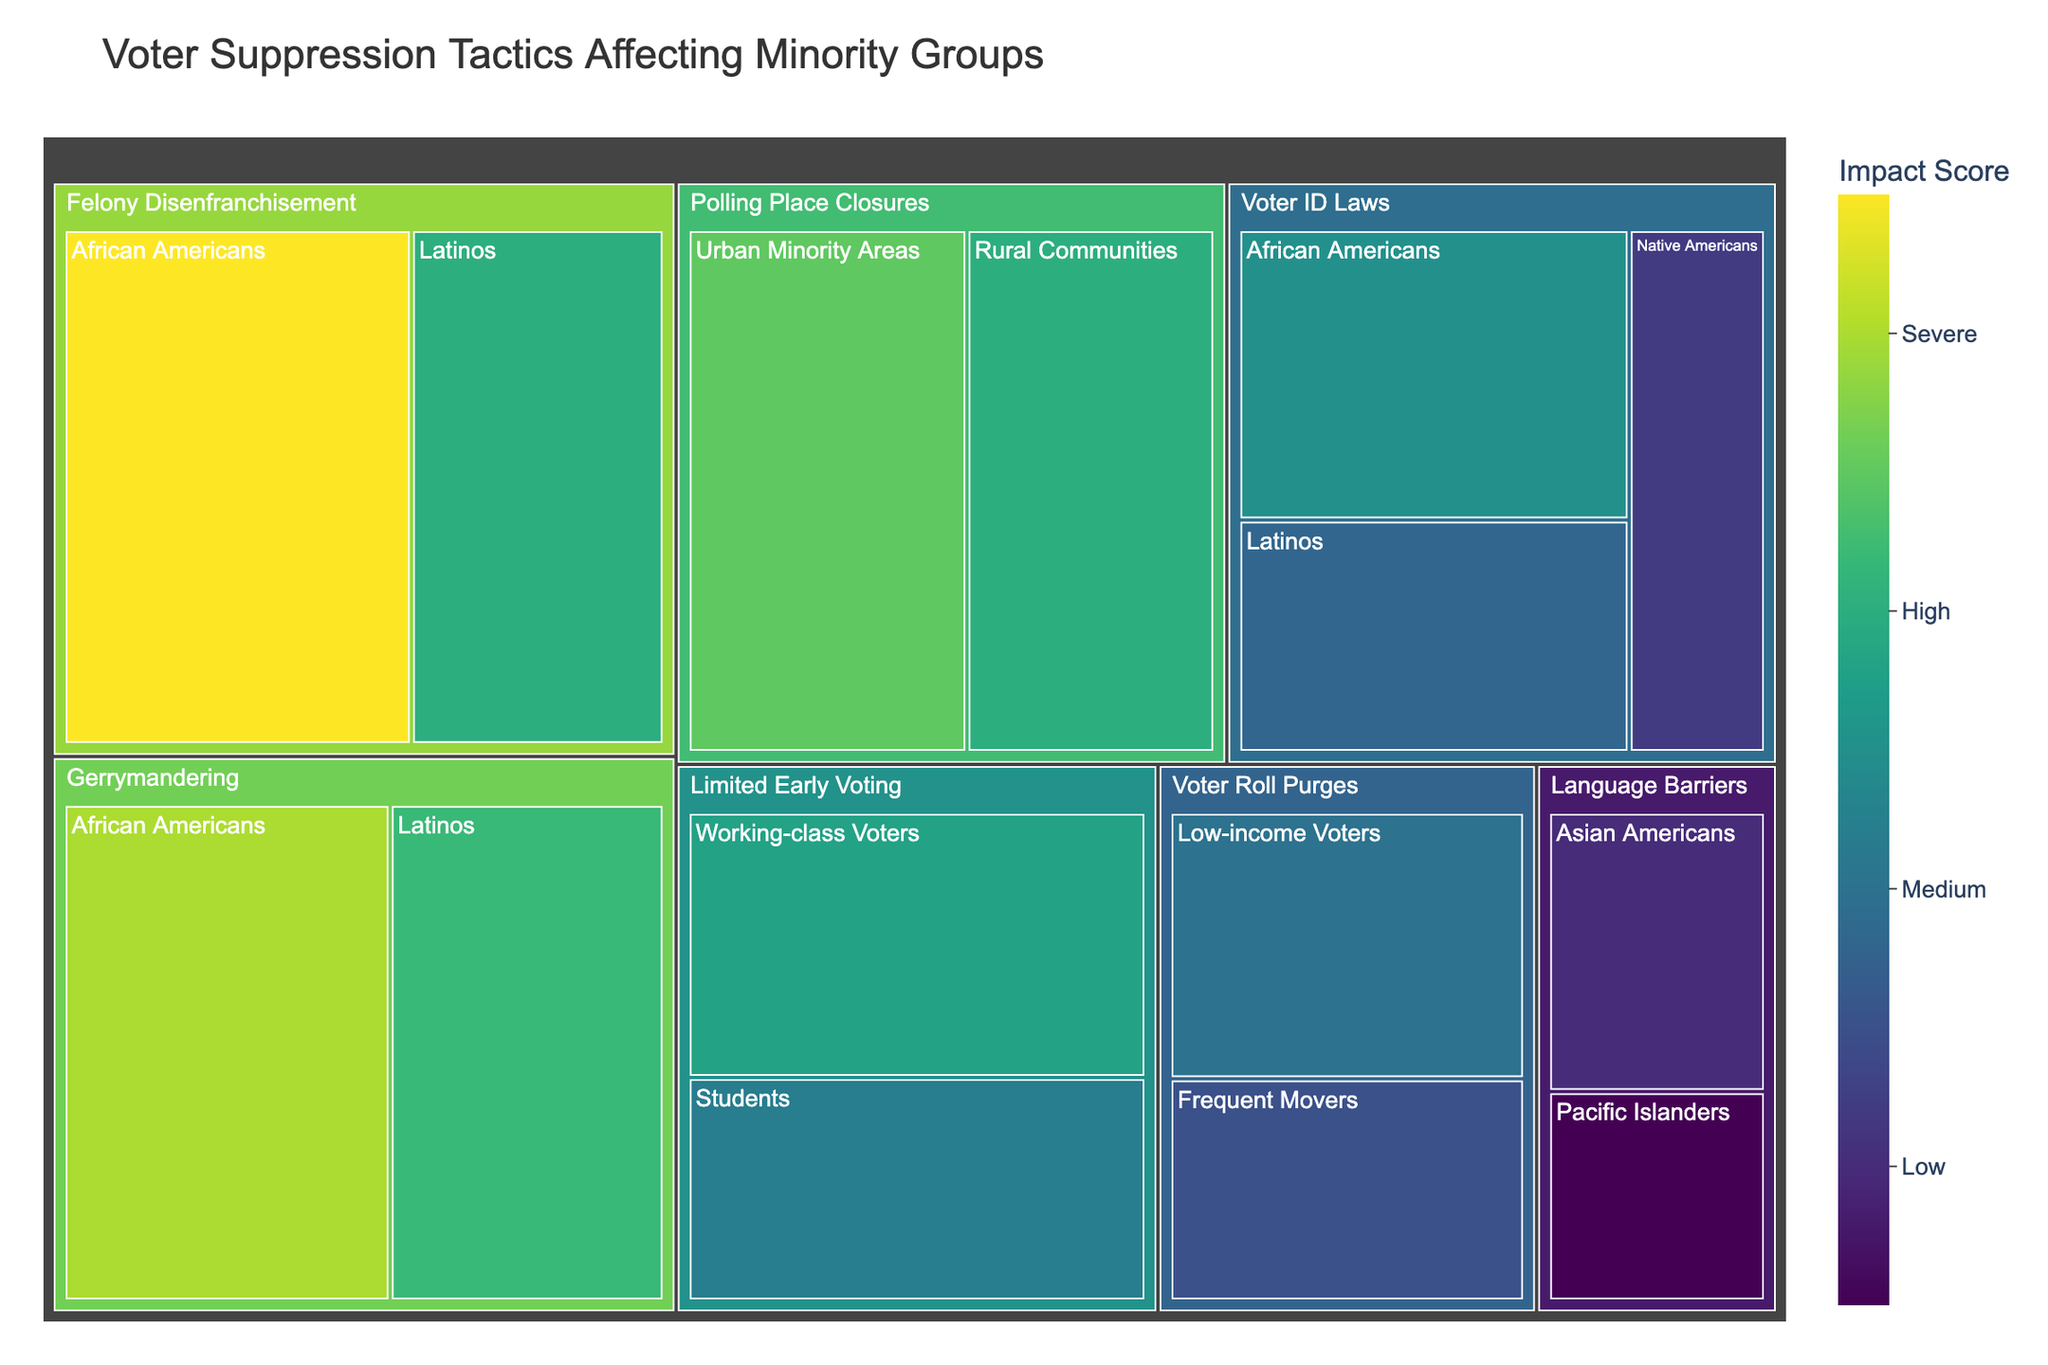What tactic has the highest impact on a particular minority group? Look for the subcategory with the largest value under each category; for example, "Felony Disenfranchisement" affects African Americans the most with a value of 55.
Answer: Felony Disenfranchisement on African Americans Which minority group is most affected by Voter ID laws? Under the "Voter ID Laws" category, compare the values: African Americans (35), Latinos (28), Native Americans (22); African Americans have the highest value.
Answer: African Americans What is the total impact score of Polling Place Closures on all affected communities? Sum the values under "Polling Place Closures": Rural Communities (40) + Urban Minority Areas (45) = 85.
Answer: 85 How does the impact of Limited Early Voting on Working-class Voters compare to that on Students? Compare the values under "Limited Early Voting": Working-class Voters (38) vs. Students (32).
Answer: Working-class Voters have a higher impact of 38 compared to Students with 32 What is the combined impact score of all Gerrymandering tactics? Sum the values under "Gerrymandering": African Americans (50) + Latinos (42) = 92.
Answer: 92 Which category has the most subcategories and what are they? Count the subcategories under each main category; the category with the highest count has 2 subcategories. For example, "Voter ID Laws" has three subcategories: African Americans, Latinos, and Native Americans.
Answer: Voter ID Laws with three subcategories What color represents the highest impact score on the treemap? Based on the color scale (Viridis), the highest impact score color represents values closer to the max, which are dark green.
Answer: Dark green What is the difference in impact scores between Gerrymandering and Voter Roll Purges on Latino communities? Compare the values: Gerrymandering (42) - Voter Roll Purges (0, as it doesn't affect Latinos) = 42.
Answer: 42 Which group is most affected by Language Barriers? Under "Language Barriers," compare the values: Asian Americans (20), Pacific Islanders (15); Asian Americans have the highest value with 20.
Answer: Asian Americans 